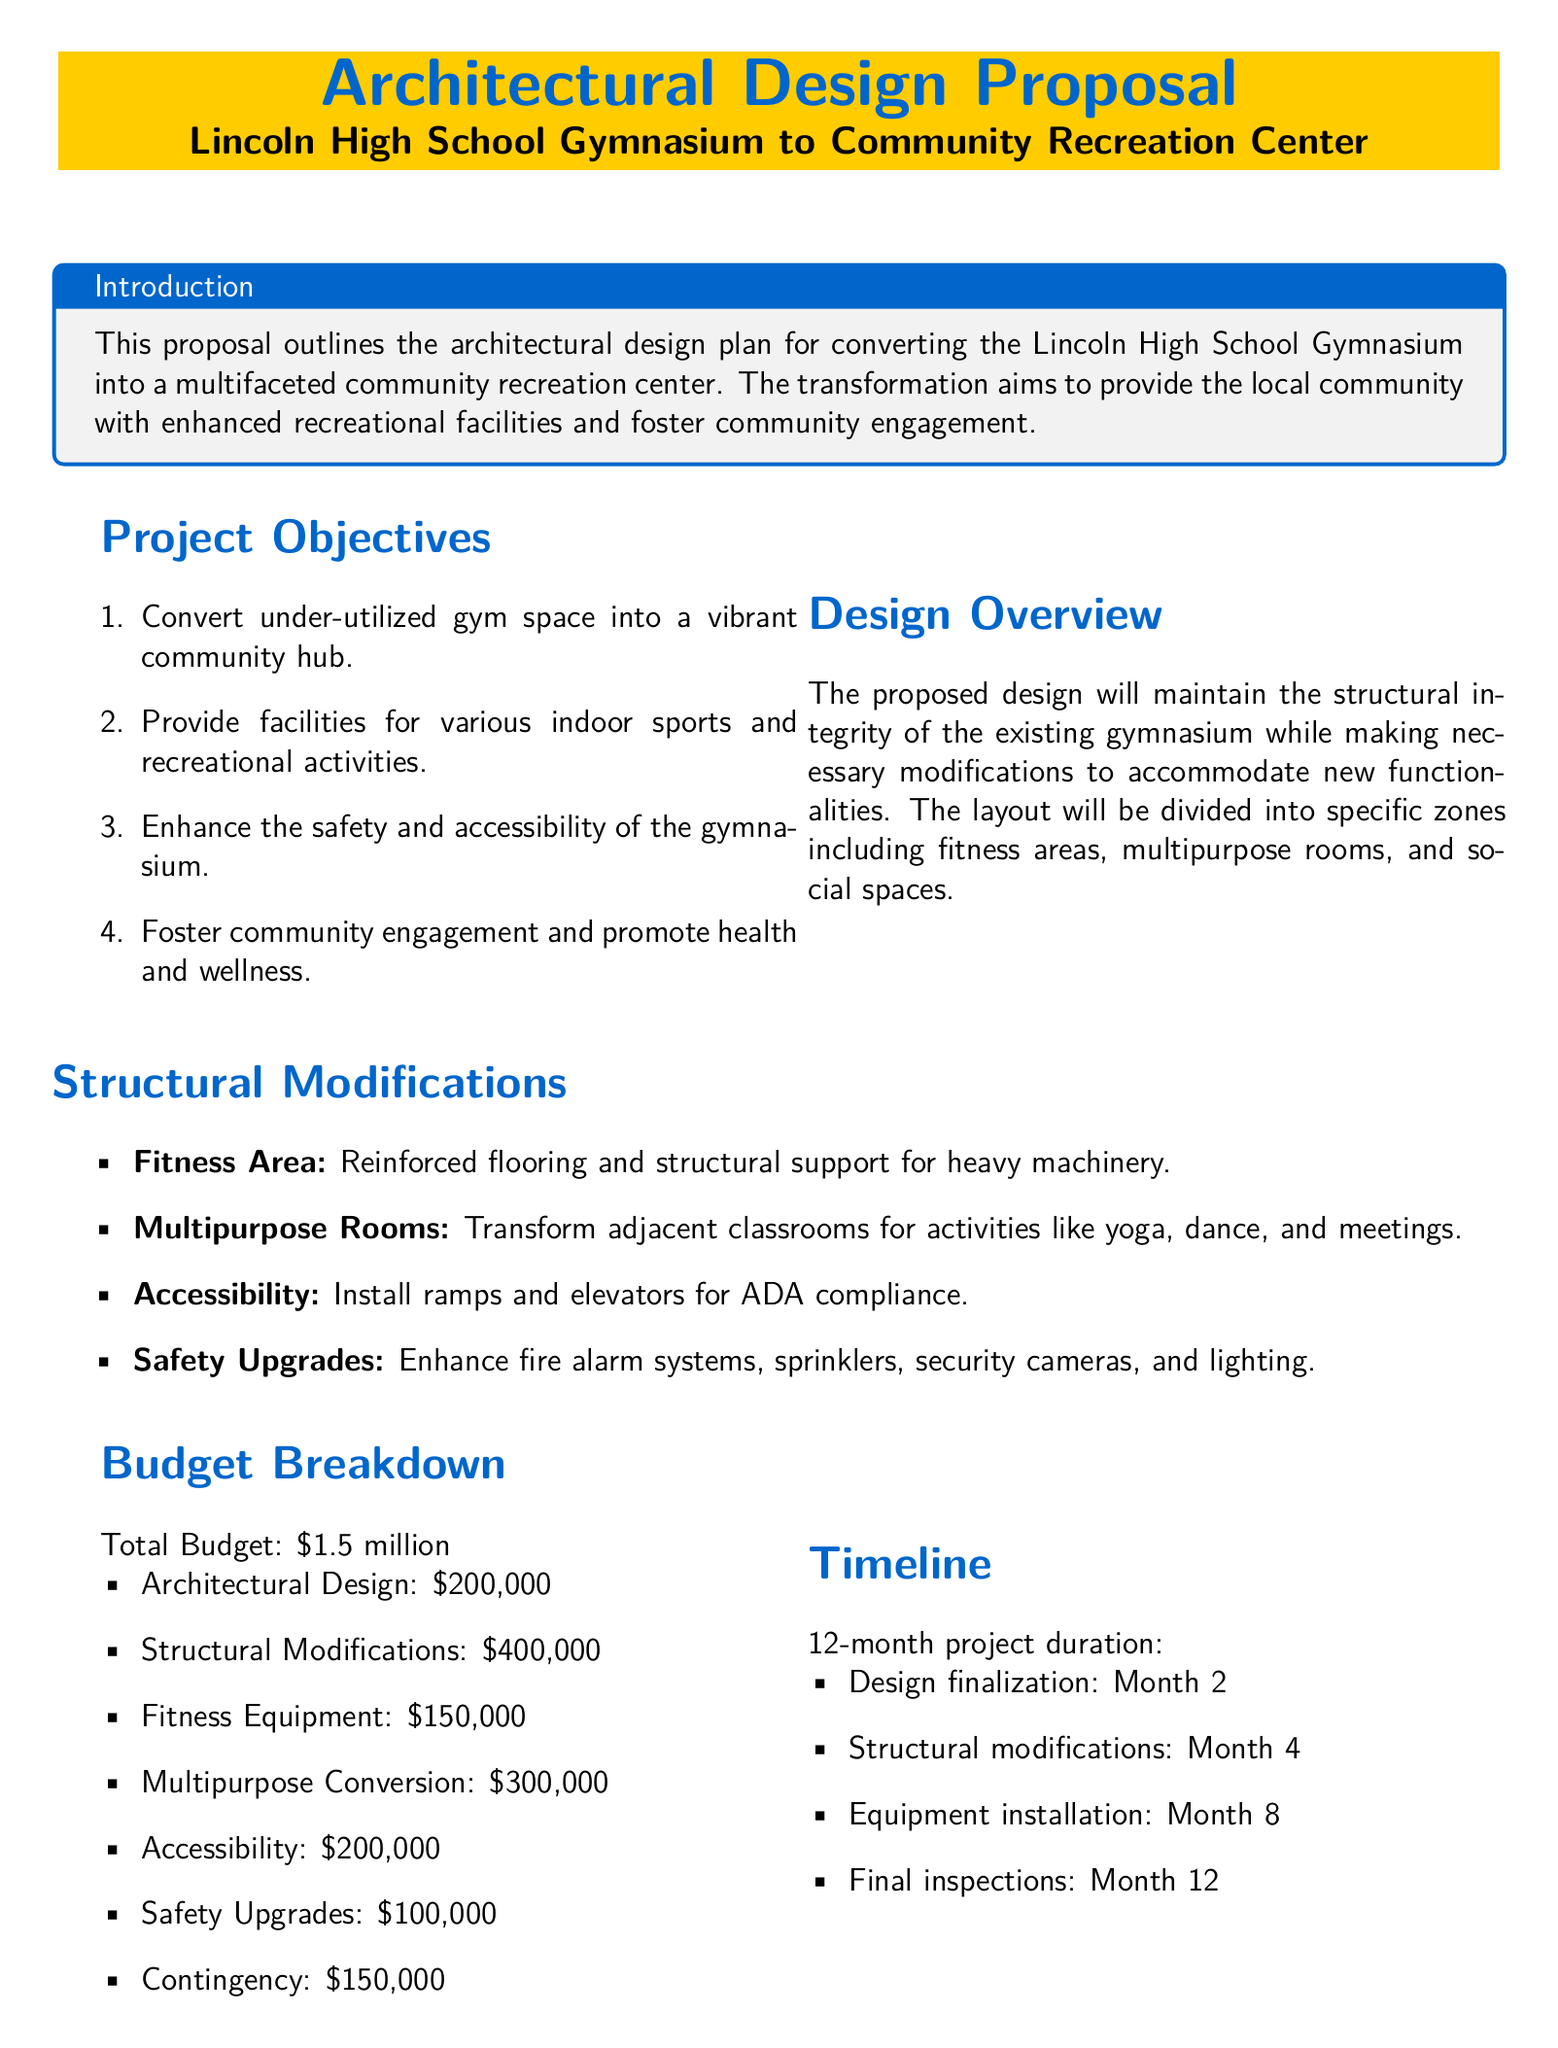What is the total budget for the project? The total budget is stated in the document under the Budget Breakdown section.
Answer: $1.5 million What is the primary objective of the project? The document outlines multiple objectives, but the primary objective is converting the gym space into a community hub.
Answer: Convert under-utilized gym space into a vibrant community hub How much is allocated for Architectural Design? The budget breakdown specifies the amount for Architectural Design.
Answer: $200,000 How long is the estimated project timeline? The document provides a specific duration for the project in the Timeline section.
Answer: 12 months What are the proposed features of the fitness area? The document lists modifications for the fitness area, which includes specific requirements.
Answer: Reinforced flooring and structural support for heavy machinery What benefit is associated with increased property value? The document mentions a direct benefit related to property value improvement within the Benefits section.
Answer: Potential for increased property value in the surrounding area When will the design finalization take place? The document specifies events in the timeline, including design finalization timing.
Answer: Month 2 What kind of upgrades are listed for safety? The document enumerates safety upgrades within the structural modifications section.
Answer: Enhance fire alarm systems, sprinklers, security cameras, and lighting 